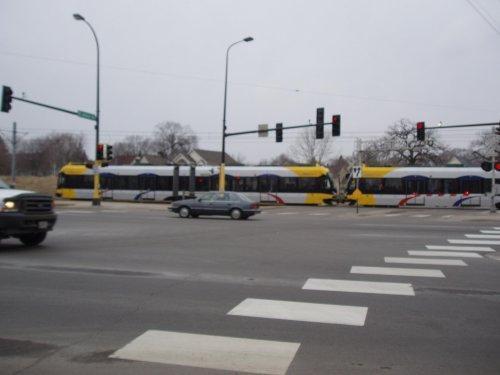How many cars are there?
Give a very brief answer. 2. How many trains are there?
Give a very brief answer. 1. How many buses are in the photo?
Give a very brief answer. 2. 